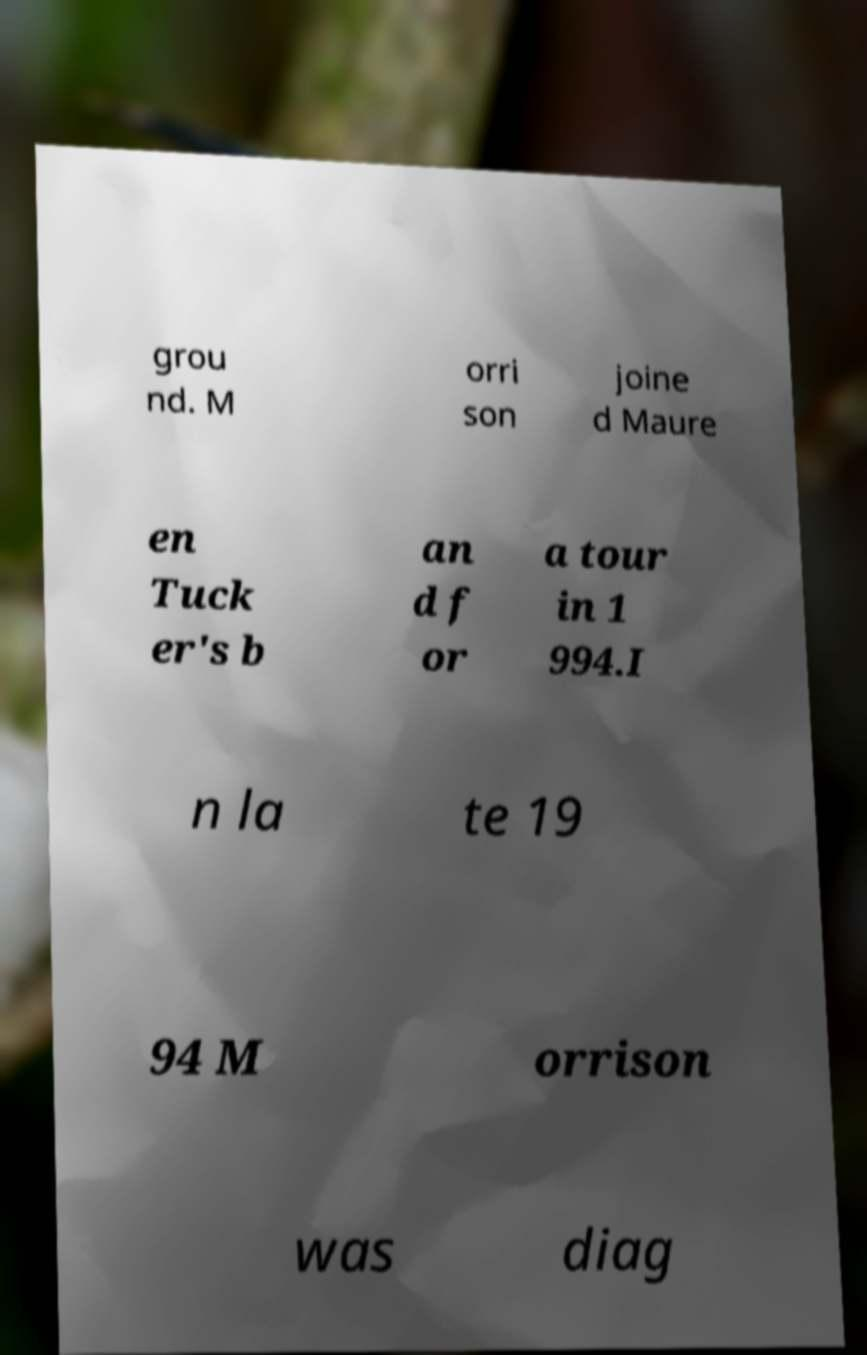What messages or text are displayed in this image? I need them in a readable, typed format. grou nd. M orri son joine d Maure en Tuck er's b an d f or a tour in 1 994.I n la te 19 94 M orrison was diag 